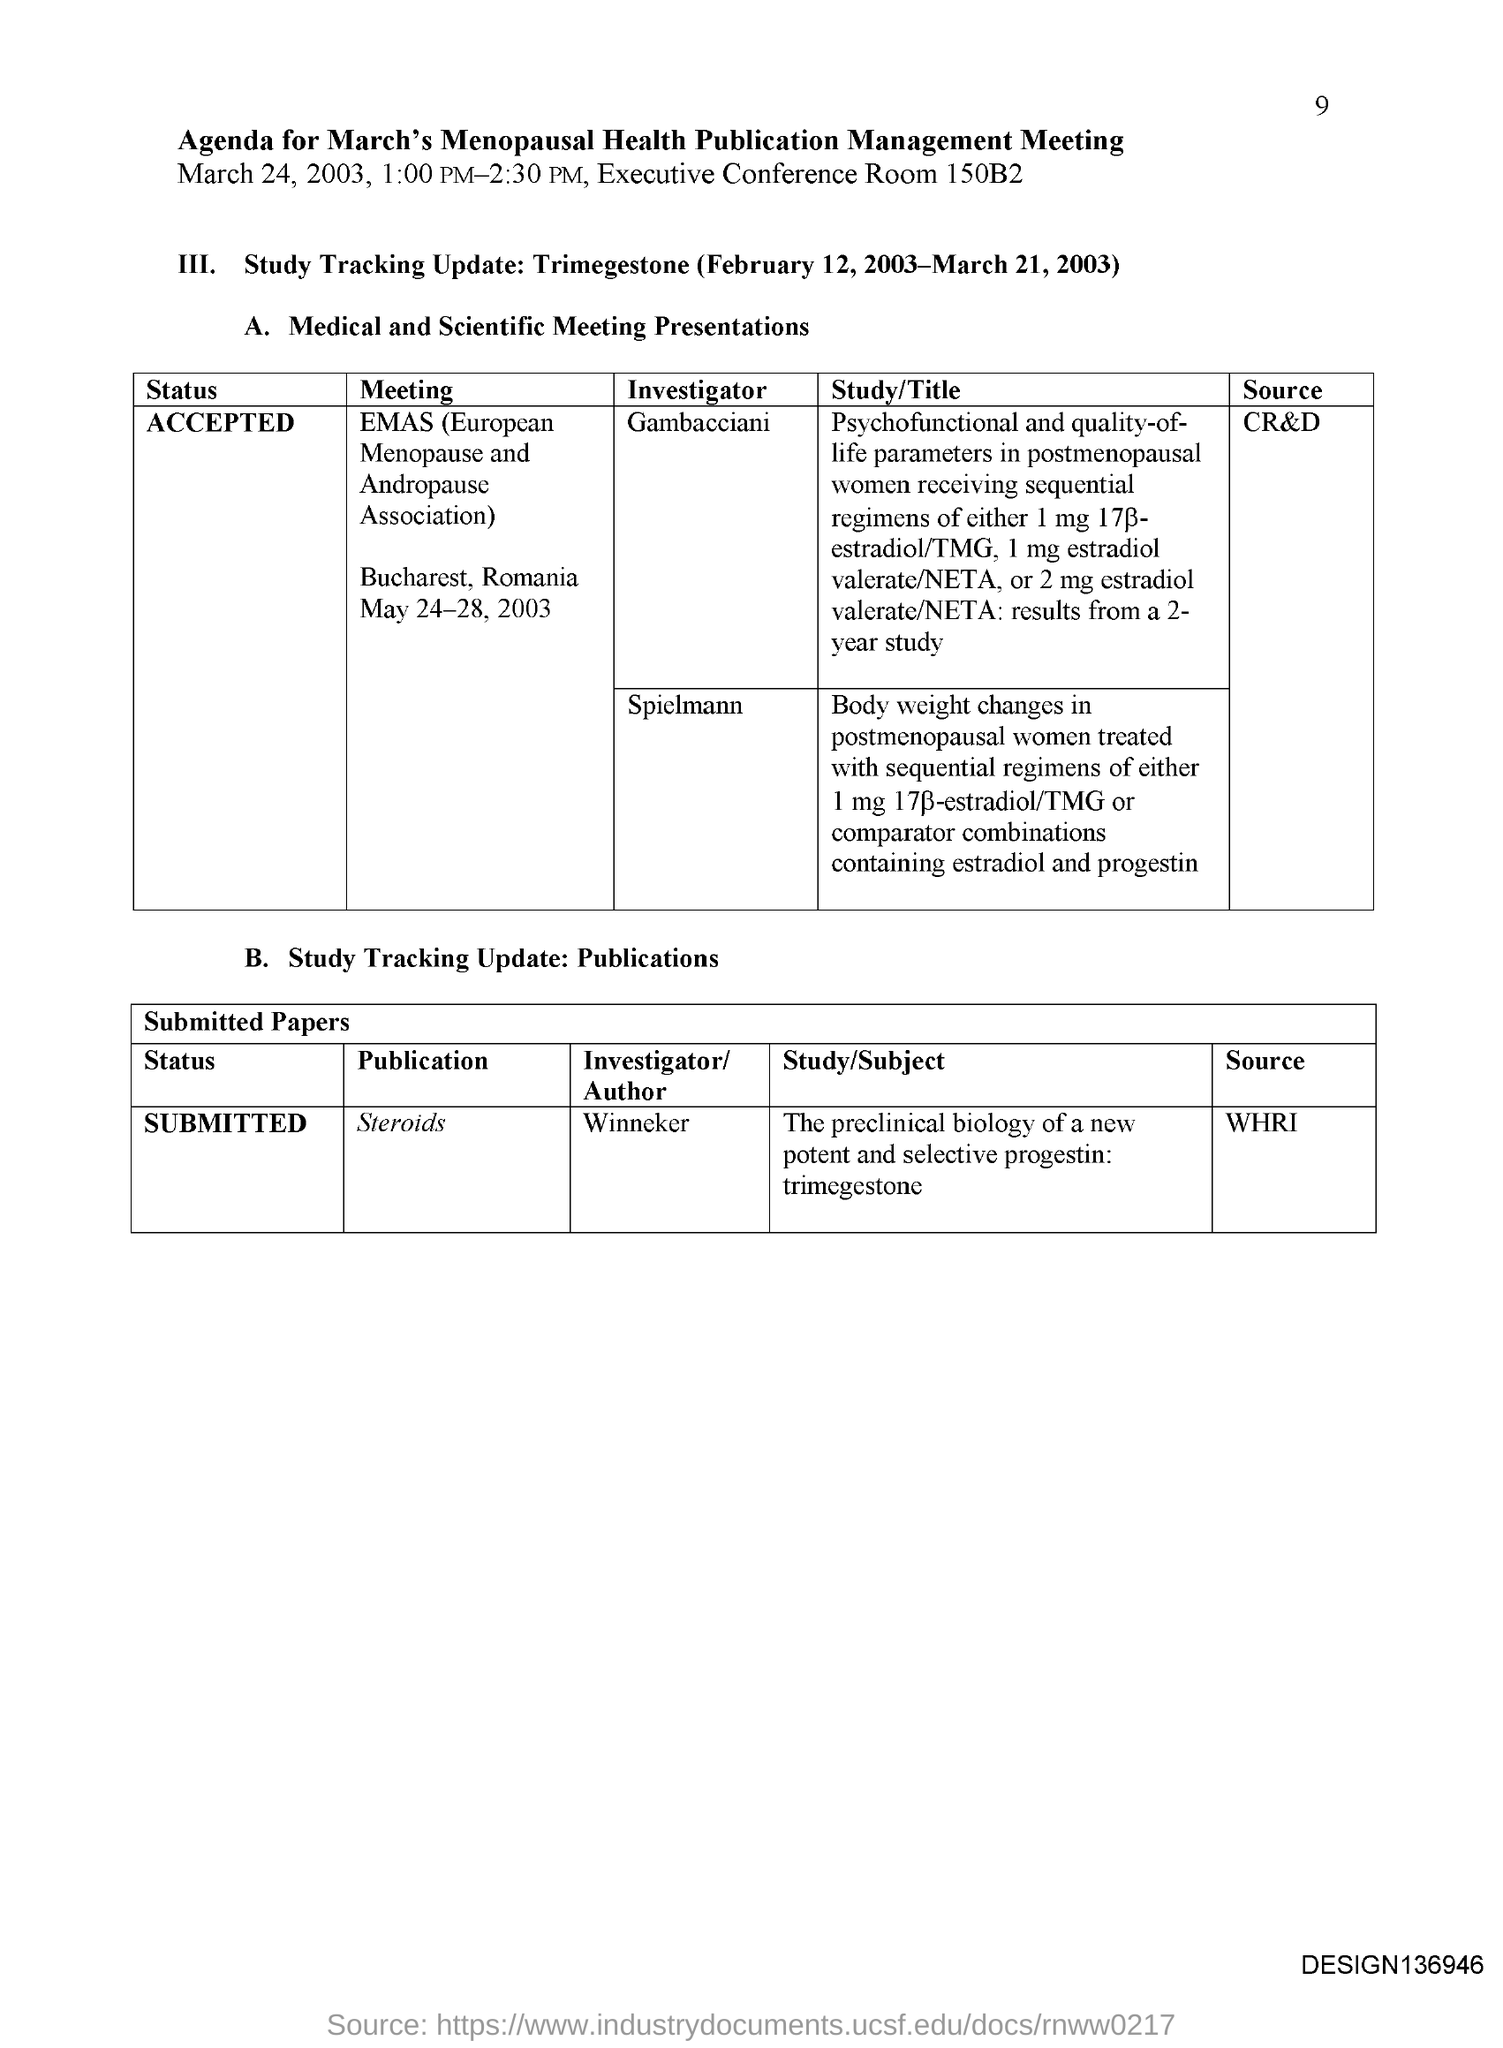List a handful of essential elements in this visual. Spielmann was an Investigator for the European Menopause and Andropause Association meeting. Gianluca Gambacciani served as an investigator for the EMAS (European Menopause and Andropause Association) meeting. The EMAS meeting is held in Bucharest, Romania. The EMAS meeting is held from May 24-28, 2003. The source for publication of information on steroids is the World Anti-Doping Agency's (WADA) Prohibited List, which is published by the World Anti-Doping Research (WHRI). 